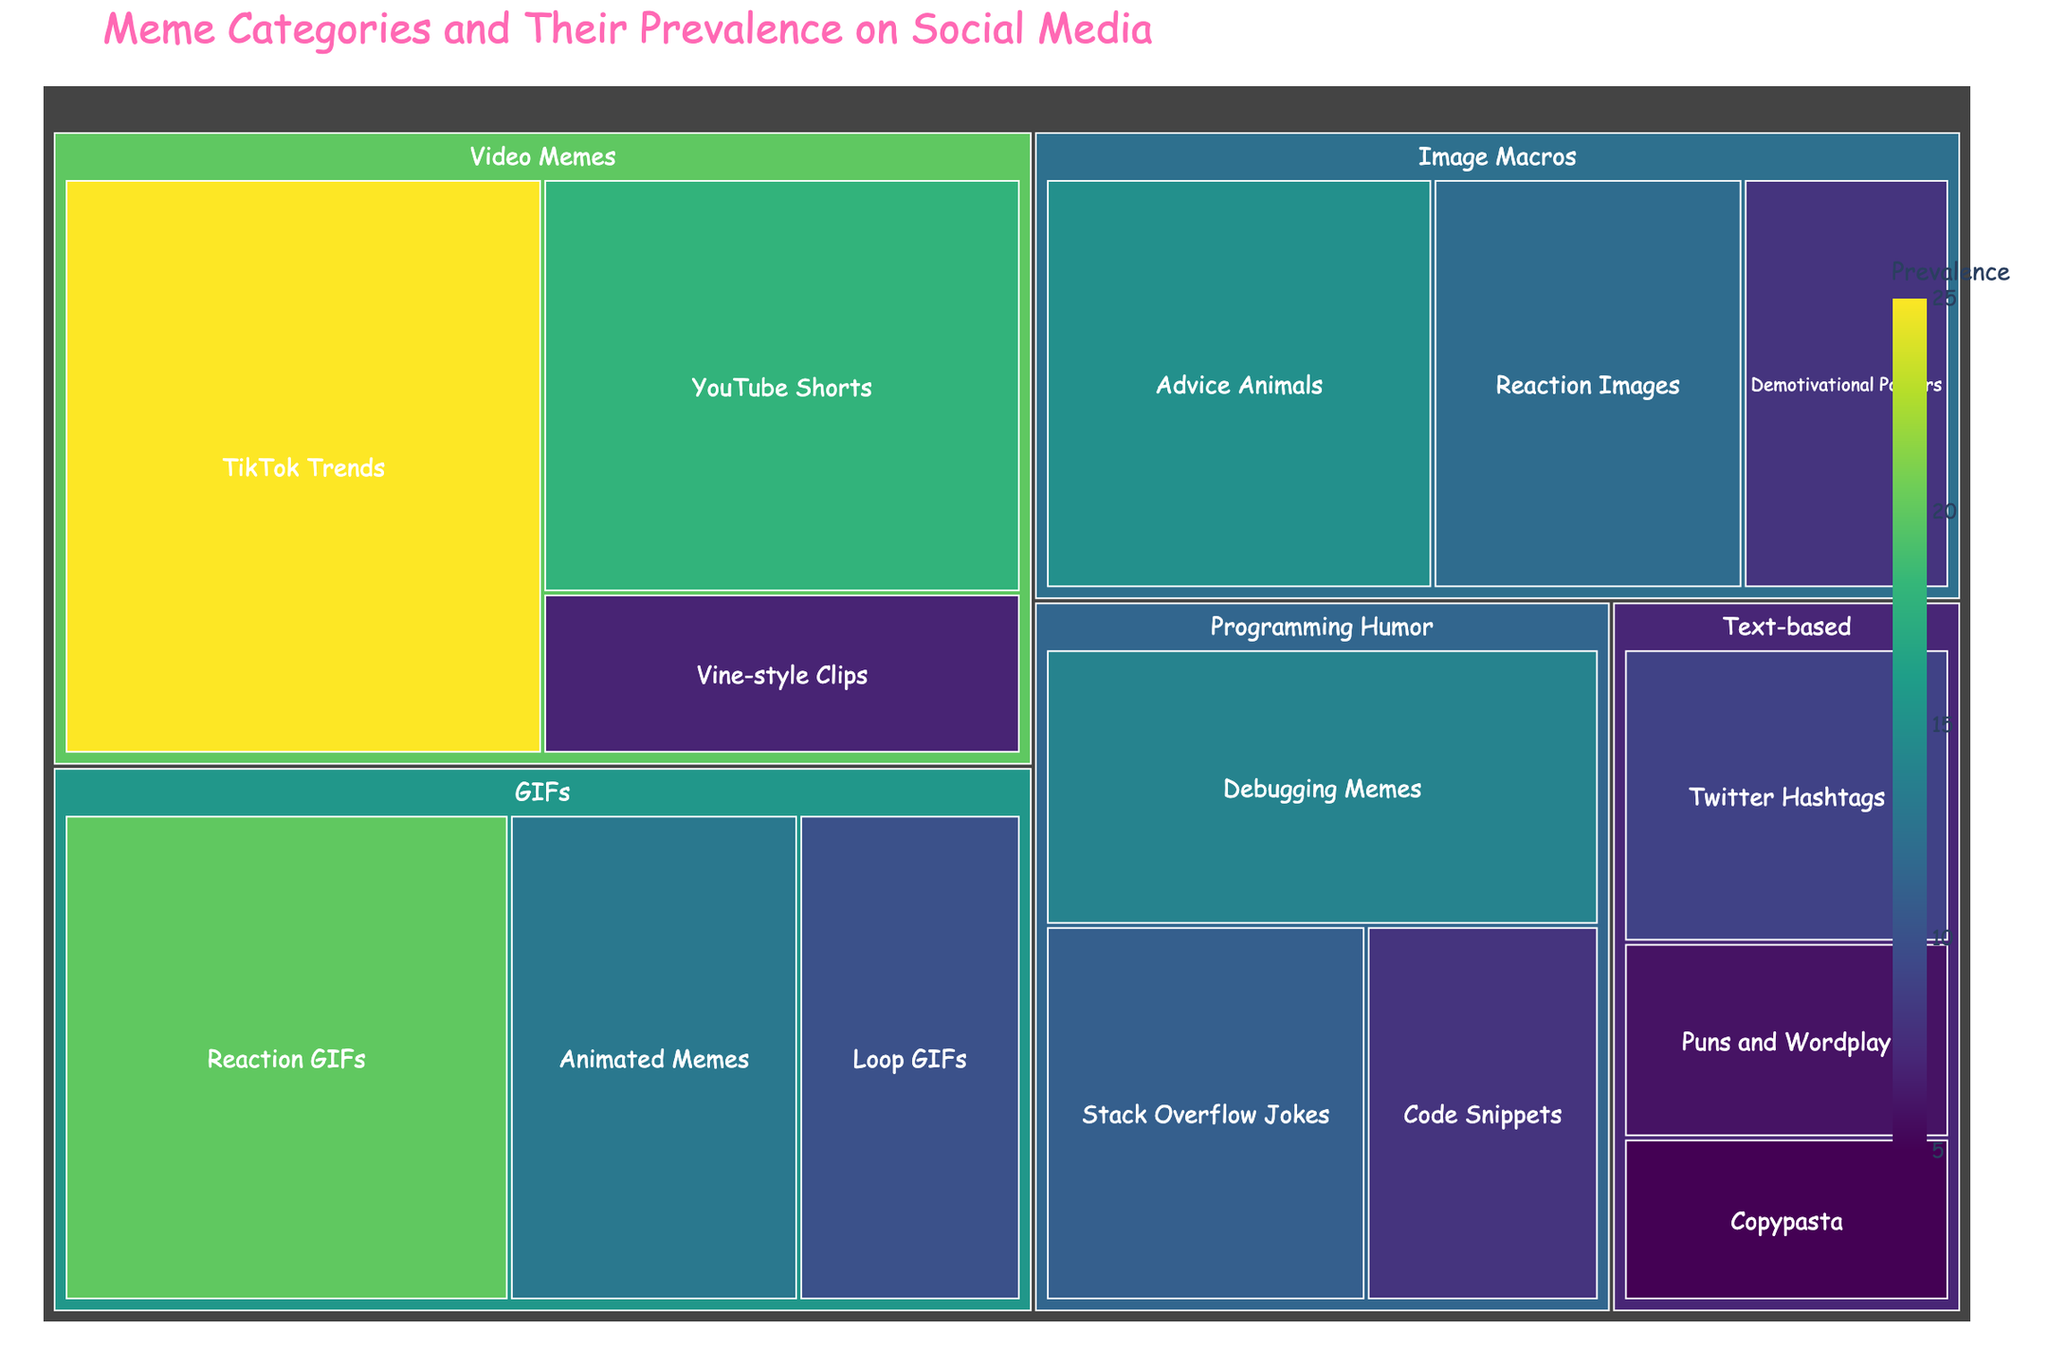What is the title of the treemap? The title is prominently displayed at the top of the treemap. It reads "Meme Categories and Their Prevalence on Social Media".
Answer: Meme Categories and Their Prevalence on Social Media Which subcategory has the highest prevalence? By looking at the area of each tile, the subcategory "TikTok Trends" within "Video Memes" clearly has the largest area, indicating the highest prevalence.
Answer: TikTok Trends How many subcategories belong to the "GIFs" category? The "GIFs" category is subdivided into smaller sections, each representing a subcategory. By counting these subdivisions, you find three subcategories: Reaction GIFs, Loop GIFs, and Animated Memes.
Answer: 3 What is the total prevalence of all "Image Macros" subcategories combined? To get the total prevalence of "Image Macros", sum up the prevalence values of its subcategories: 15 (Advice Animals) + 12 (Reaction Images) + 8 (Demotivational Posters). The total is 35.
Answer: 35 Which is more prevalent, "Stack Overflow Jokes" in Programming Humor or "Demotivational Posters" in Image Macros? Compare the prevalence of "Stack Overflow Jokes" (11) with "Demotivational Posters" (8). Since 11 is greater than 8, "Stack Overflow Jokes" is more prevalent.
Answer: Stack Overflow Jokes What is the prevalence range of subcategories within the "Text-based" category? The prevalence values for subcategories within "Text-based" are 5 (Copypasta), 9 (Twitter Hashtags), and 6 (Puns and Wordplay). The range is calculated as the difference between the maximum and minimum values: 9 - 5 = 4.
Answer: 4 Among "Programming Humor" subcategories, which has the second highest prevalence? The prevalence values are 11 (Stack Overflow Jokes), 8 (Code Snippets), and 14 (Debugging Memes). The second highest value is 11, which corresponds to "Stack Overflow Jokes".
Answer: Stack Overflow Jokes Which is the least prevalent subcategory overall? By looking at the area of the smallest tile, the subcategory "Copypasta" within "Text-based" has the smallest area, indicating the least prevalence, which is 5.
Answer: Copypasta What is the total prevalence of all "Video Memes" subcategories combined? To get the total prevalence of "Video Memes", sum up the prevalence values of its subcategories: 25 (TikTok Trends) + 18 (YouTube Shorts) + 7 (Vine-style Clips). The total is 50.
Answer: 50 